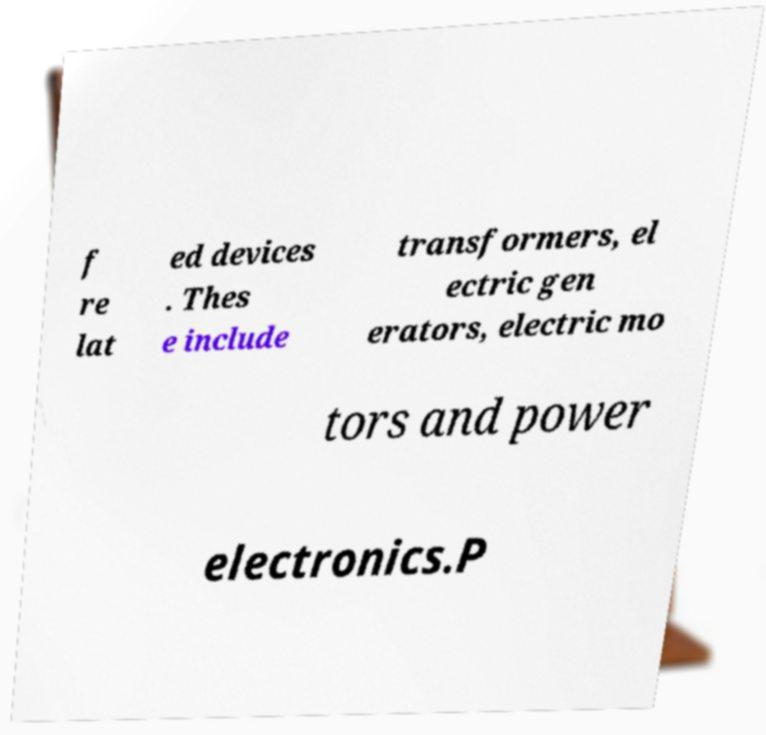Can you accurately transcribe the text from the provided image for me? f re lat ed devices . Thes e include transformers, el ectric gen erators, electric mo tors and power electronics.P 